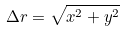Convert formula to latex. <formula><loc_0><loc_0><loc_500><loc_500>\Delta r = \sqrt { x ^ { 2 } + y ^ { 2 } }</formula> 